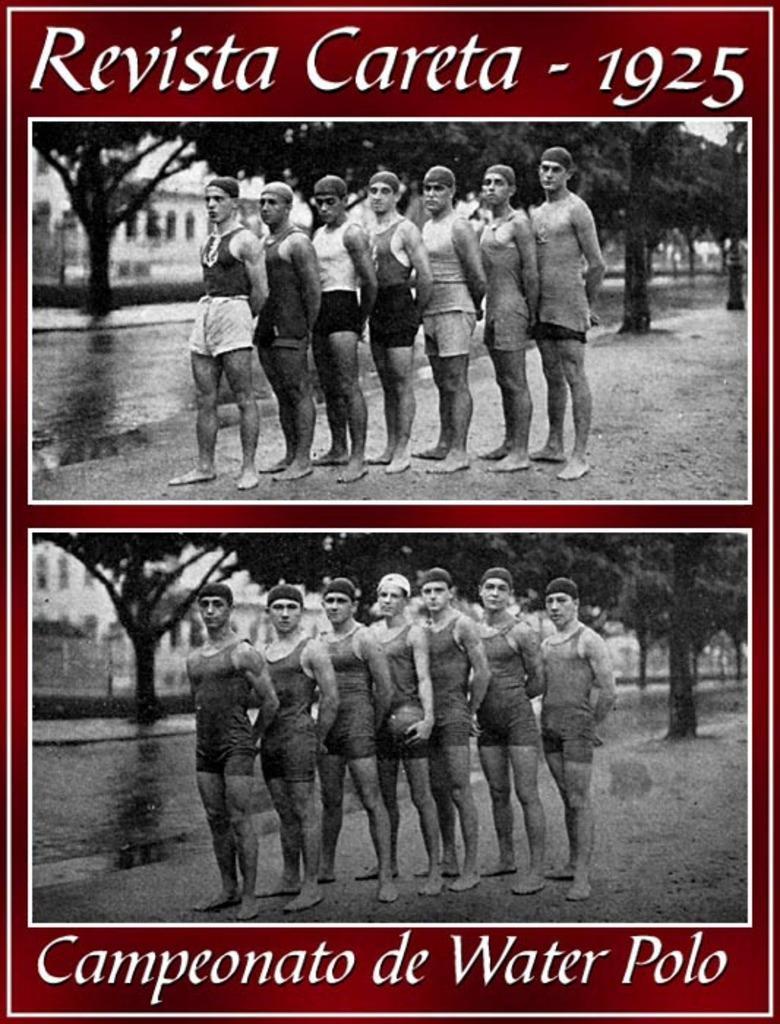Describe this image in one or two sentences. This image consists of a poster. Here I can see two images. In the top image I can see few persons are standing in a line , facing towards the left side and giving pose for the picture. In the background I can see some trees and a building. In the bottom image I can see few men are standing and giving pose for the picture. The man who is standing in the middle is holding a ball in hands. In the background I can see some trees and a building. On this image I can see some text. 